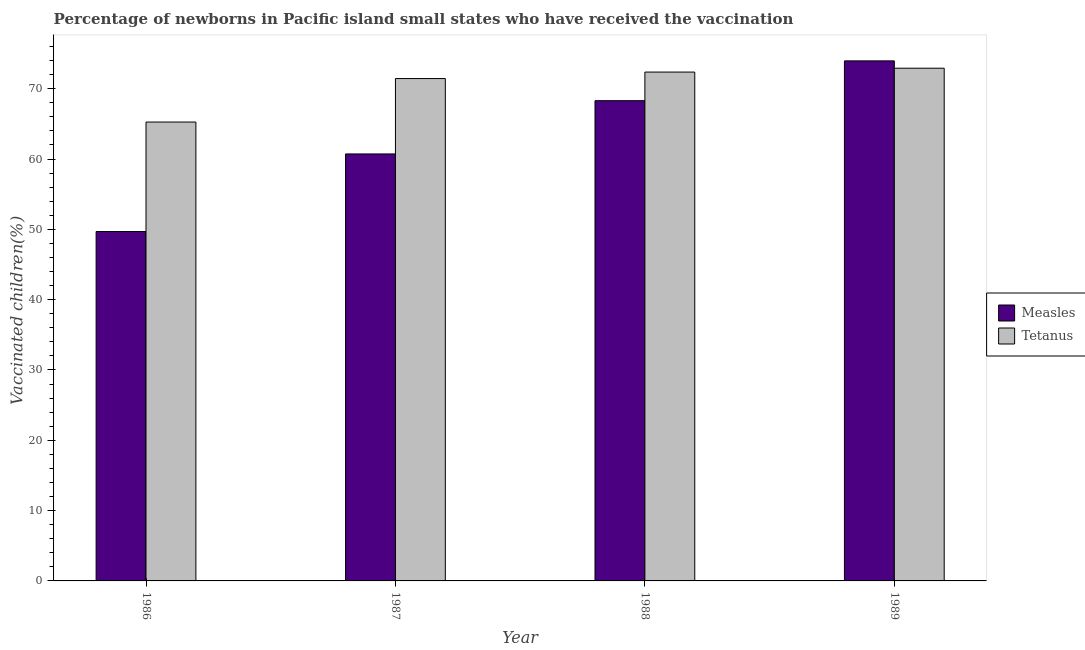How many different coloured bars are there?
Ensure brevity in your answer.  2. How many groups of bars are there?
Make the answer very short. 4. Are the number of bars on each tick of the X-axis equal?
Your response must be concise. Yes. How many bars are there on the 4th tick from the left?
Offer a terse response. 2. How many bars are there on the 4th tick from the right?
Your response must be concise. 2. What is the label of the 3rd group of bars from the left?
Give a very brief answer. 1988. What is the percentage of newborns who received vaccination for tetanus in 1987?
Provide a short and direct response. 71.45. Across all years, what is the maximum percentage of newborns who received vaccination for measles?
Provide a short and direct response. 73.96. Across all years, what is the minimum percentage of newborns who received vaccination for measles?
Your response must be concise. 49.69. In which year was the percentage of newborns who received vaccination for measles maximum?
Give a very brief answer. 1989. What is the total percentage of newborns who received vaccination for tetanus in the graph?
Provide a succinct answer. 282.01. What is the difference between the percentage of newborns who received vaccination for measles in 1988 and that in 1989?
Make the answer very short. -5.66. What is the difference between the percentage of newborns who received vaccination for tetanus in 1989 and the percentage of newborns who received vaccination for measles in 1987?
Keep it short and to the point. 1.47. What is the average percentage of newborns who received vaccination for tetanus per year?
Offer a very short reply. 70.5. What is the ratio of the percentage of newborns who received vaccination for tetanus in 1986 to that in 1987?
Your answer should be compact. 0.91. Is the difference between the percentage of newborns who received vaccination for tetanus in 1987 and 1988 greater than the difference between the percentage of newborns who received vaccination for measles in 1987 and 1988?
Your response must be concise. No. What is the difference between the highest and the second highest percentage of newborns who received vaccination for measles?
Make the answer very short. 5.66. What is the difference between the highest and the lowest percentage of newborns who received vaccination for measles?
Provide a short and direct response. 24.27. In how many years, is the percentage of newborns who received vaccination for tetanus greater than the average percentage of newborns who received vaccination for tetanus taken over all years?
Your answer should be compact. 3. What does the 2nd bar from the left in 1988 represents?
Make the answer very short. Tetanus. What does the 1st bar from the right in 1987 represents?
Provide a short and direct response. Tetanus. Are all the bars in the graph horizontal?
Provide a succinct answer. No. How many years are there in the graph?
Give a very brief answer. 4. What is the difference between two consecutive major ticks on the Y-axis?
Ensure brevity in your answer.  10. How many legend labels are there?
Keep it short and to the point. 2. How are the legend labels stacked?
Make the answer very short. Vertical. What is the title of the graph?
Offer a terse response. Percentage of newborns in Pacific island small states who have received the vaccination. What is the label or title of the Y-axis?
Ensure brevity in your answer.  Vaccinated children(%)
. What is the Vaccinated children(%)
 in Measles in 1986?
Provide a short and direct response. 49.69. What is the Vaccinated children(%)
 in Tetanus in 1986?
Your answer should be compact. 65.27. What is the Vaccinated children(%)
 in Measles in 1987?
Make the answer very short. 60.73. What is the Vaccinated children(%)
 in Tetanus in 1987?
Ensure brevity in your answer.  71.45. What is the Vaccinated children(%)
 in Measles in 1988?
Make the answer very short. 68.3. What is the Vaccinated children(%)
 of Tetanus in 1988?
Provide a succinct answer. 72.37. What is the Vaccinated children(%)
 in Measles in 1989?
Offer a terse response. 73.96. What is the Vaccinated children(%)
 of Tetanus in 1989?
Your response must be concise. 72.92. Across all years, what is the maximum Vaccinated children(%)
 of Measles?
Provide a short and direct response. 73.96. Across all years, what is the maximum Vaccinated children(%)
 in Tetanus?
Your answer should be very brief. 72.92. Across all years, what is the minimum Vaccinated children(%)
 of Measles?
Your answer should be compact. 49.69. Across all years, what is the minimum Vaccinated children(%)
 of Tetanus?
Offer a terse response. 65.27. What is the total Vaccinated children(%)
 of Measles in the graph?
Give a very brief answer. 252.69. What is the total Vaccinated children(%)
 of Tetanus in the graph?
Your answer should be compact. 282.01. What is the difference between the Vaccinated children(%)
 in Measles in 1986 and that in 1987?
Offer a terse response. -11.04. What is the difference between the Vaccinated children(%)
 of Tetanus in 1986 and that in 1987?
Your answer should be very brief. -6.18. What is the difference between the Vaccinated children(%)
 of Measles in 1986 and that in 1988?
Keep it short and to the point. -18.61. What is the difference between the Vaccinated children(%)
 in Tetanus in 1986 and that in 1988?
Keep it short and to the point. -7.11. What is the difference between the Vaccinated children(%)
 in Measles in 1986 and that in 1989?
Provide a succinct answer. -24.27. What is the difference between the Vaccinated children(%)
 in Tetanus in 1986 and that in 1989?
Provide a succinct answer. -7.66. What is the difference between the Vaccinated children(%)
 of Measles in 1987 and that in 1988?
Your answer should be very brief. -7.58. What is the difference between the Vaccinated children(%)
 of Tetanus in 1987 and that in 1988?
Your answer should be very brief. -0.92. What is the difference between the Vaccinated children(%)
 in Measles in 1987 and that in 1989?
Your answer should be compact. -13.24. What is the difference between the Vaccinated children(%)
 of Tetanus in 1987 and that in 1989?
Your answer should be very brief. -1.47. What is the difference between the Vaccinated children(%)
 of Measles in 1988 and that in 1989?
Provide a short and direct response. -5.66. What is the difference between the Vaccinated children(%)
 in Tetanus in 1988 and that in 1989?
Ensure brevity in your answer.  -0.55. What is the difference between the Vaccinated children(%)
 of Measles in 1986 and the Vaccinated children(%)
 of Tetanus in 1987?
Give a very brief answer. -21.76. What is the difference between the Vaccinated children(%)
 of Measles in 1986 and the Vaccinated children(%)
 of Tetanus in 1988?
Make the answer very short. -22.68. What is the difference between the Vaccinated children(%)
 in Measles in 1986 and the Vaccinated children(%)
 in Tetanus in 1989?
Provide a short and direct response. -23.23. What is the difference between the Vaccinated children(%)
 of Measles in 1987 and the Vaccinated children(%)
 of Tetanus in 1988?
Offer a very short reply. -11.64. What is the difference between the Vaccinated children(%)
 in Measles in 1987 and the Vaccinated children(%)
 in Tetanus in 1989?
Your answer should be compact. -12.19. What is the difference between the Vaccinated children(%)
 of Measles in 1988 and the Vaccinated children(%)
 of Tetanus in 1989?
Keep it short and to the point. -4.62. What is the average Vaccinated children(%)
 in Measles per year?
Offer a very short reply. 63.17. What is the average Vaccinated children(%)
 in Tetanus per year?
Give a very brief answer. 70.5. In the year 1986, what is the difference between the Vaccinated children(%)
 of Measles and Vaccinated children(%)
 of Tetanus?
Offer a terse response. -15.57. In the year 1987, what is the difference between the Vaccinated children(%)
 in Measles and Vaccinated children(%)
 in Tetanus?
Provide a succinct answer. -10.72. In the year 1988, what is the difference between the Vaccinated children(%)
 in Measles and Vaccinated children(%)
 in Tetanus?
Give a very brief answer. -4.07. In the year 1989, what is the difference between the Vaccinated children(%)
 of Measles and Vaccinated children(%)
 of Tetanus?
Your response must be concise. 1.04. What is the ratio of the Vaccinated children(%)
 in Measles in 1986 to that in 1987?
Your answer should be compact. 0.82. What is the ratio of the Vaccinated children(%)
 of Tetanus in 1986 to that in 1987?
Your answer should be compact. 0.91. What is the ratio of the Vaccinated children(%)
 in Measles in 1986 to that in 1988?
Your response must be concise. 0.73. What is the ratio of the Vaccinated children(%)
 in Tetanus in 1986 to that in 1988?
Ensure brevity in your answer.  0.9. What is the ratio of the Vaccinated children(%)
 in Measles in 1986 to that in 1989?
Give a very brief answer. 0.67. What is the ratio of the Vaccinated children(%)
 in Tetanus in 1986 to that in 1989?
Ensure brevity in your answer.  0.9. What is the ratio of the Vaccinated children(%)
 of Measles in 1987 to that in 1988?
Offer a terse response. 0.89. What is the ratio of the Vaccinated children(%)
 in Tetanus in 1987 to that in 1988?
Give a very brief answer. 0.99. What is the ratio of the Vaccinated children(%)
 of Measles in 1987 to that in 1989?
Provide a succinct answer. 0.82. What is the ratio of the Vaccinated children(%)
 of Tetanus in 1987 to that in 1989?
Keep it short and to the point. 0.98. What is the ratio of the Vaccinated children(%)
 of Measles in 1988 to that in 1989?
Give a very brief answer. 0.92. What is the difference between the highest and the second highest Vaccinated children(%)
 of Measles?
Your answer should be compact. 5.66. What is the difference between the highest and the second highest Vaccinated children(%)
 of Tetanus?
Offer a very short reply. 0.55. What is the difference between the highest and the lowest Vaccinated children(%)
 in Measles?
Ensure brevity in your answer.  24.27. What is the difference between the highest and the lowest Vaccinated children(%)
 in Tetanus?
Provide a short and direct response. 7.66. 